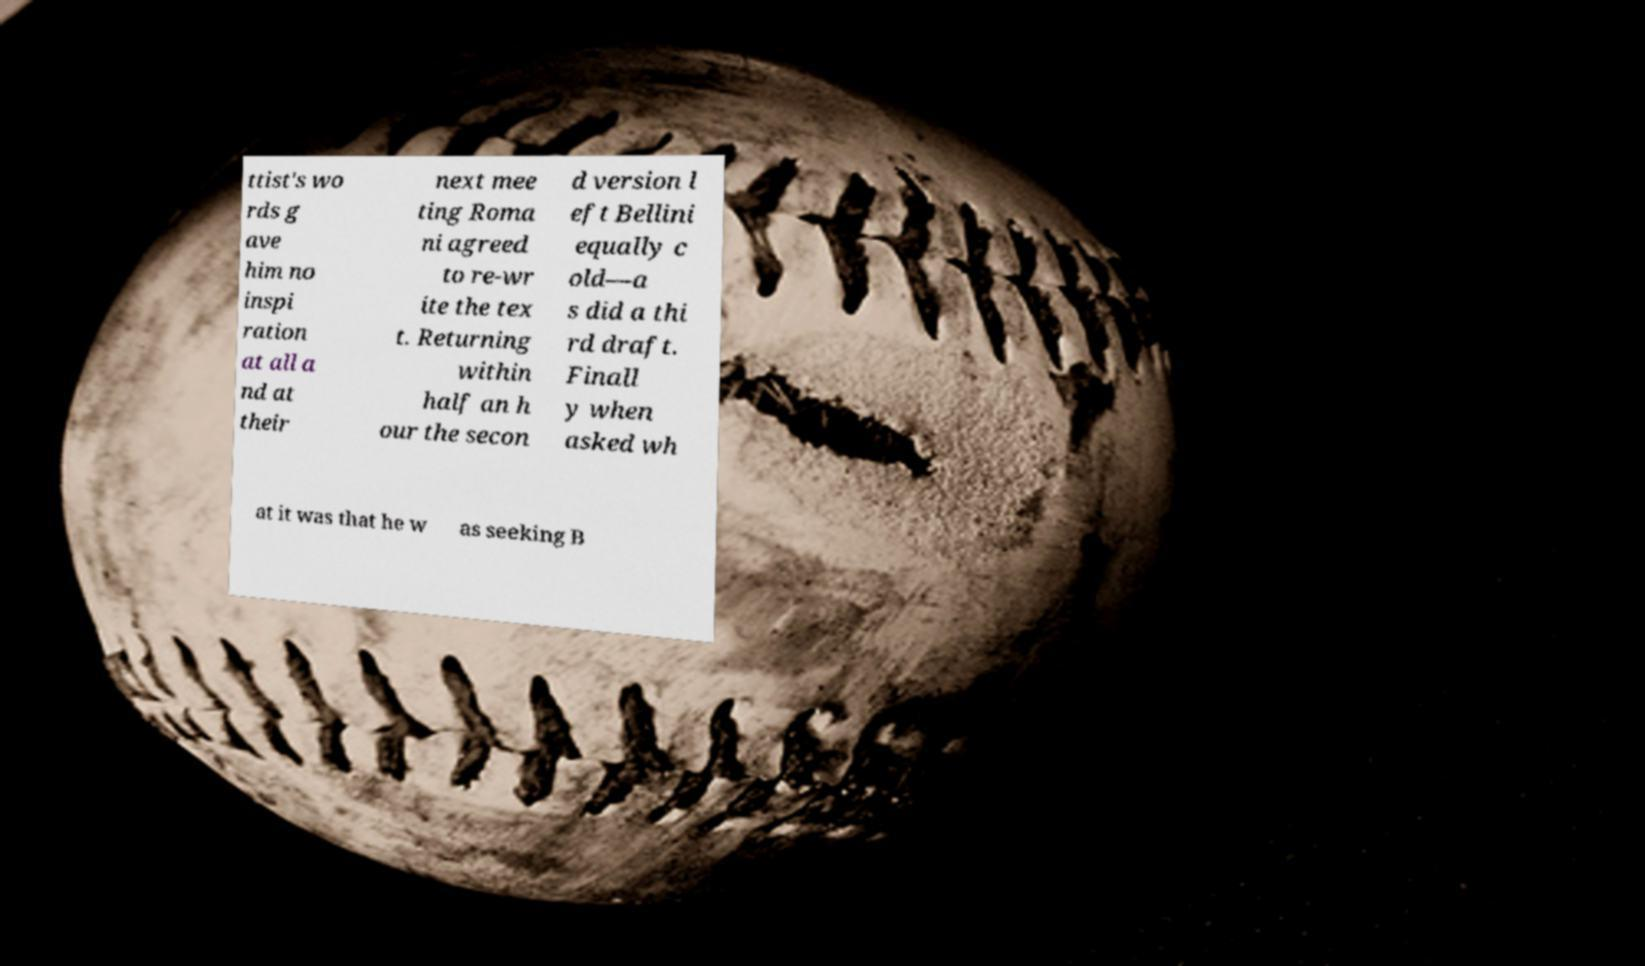There's text embedded in this image that I need extracted. Can you transcribe it verbatim? ttist's wo rds g ave him no inspi ration at all a nd at their next mee ting Roma ni agreed to re-wr ite the tex t. Returning within half an h our the secon d version l eft Bellini equally c old—a s did a thi rd draft. Finall y when asked wh at it was that he w as seeking B 